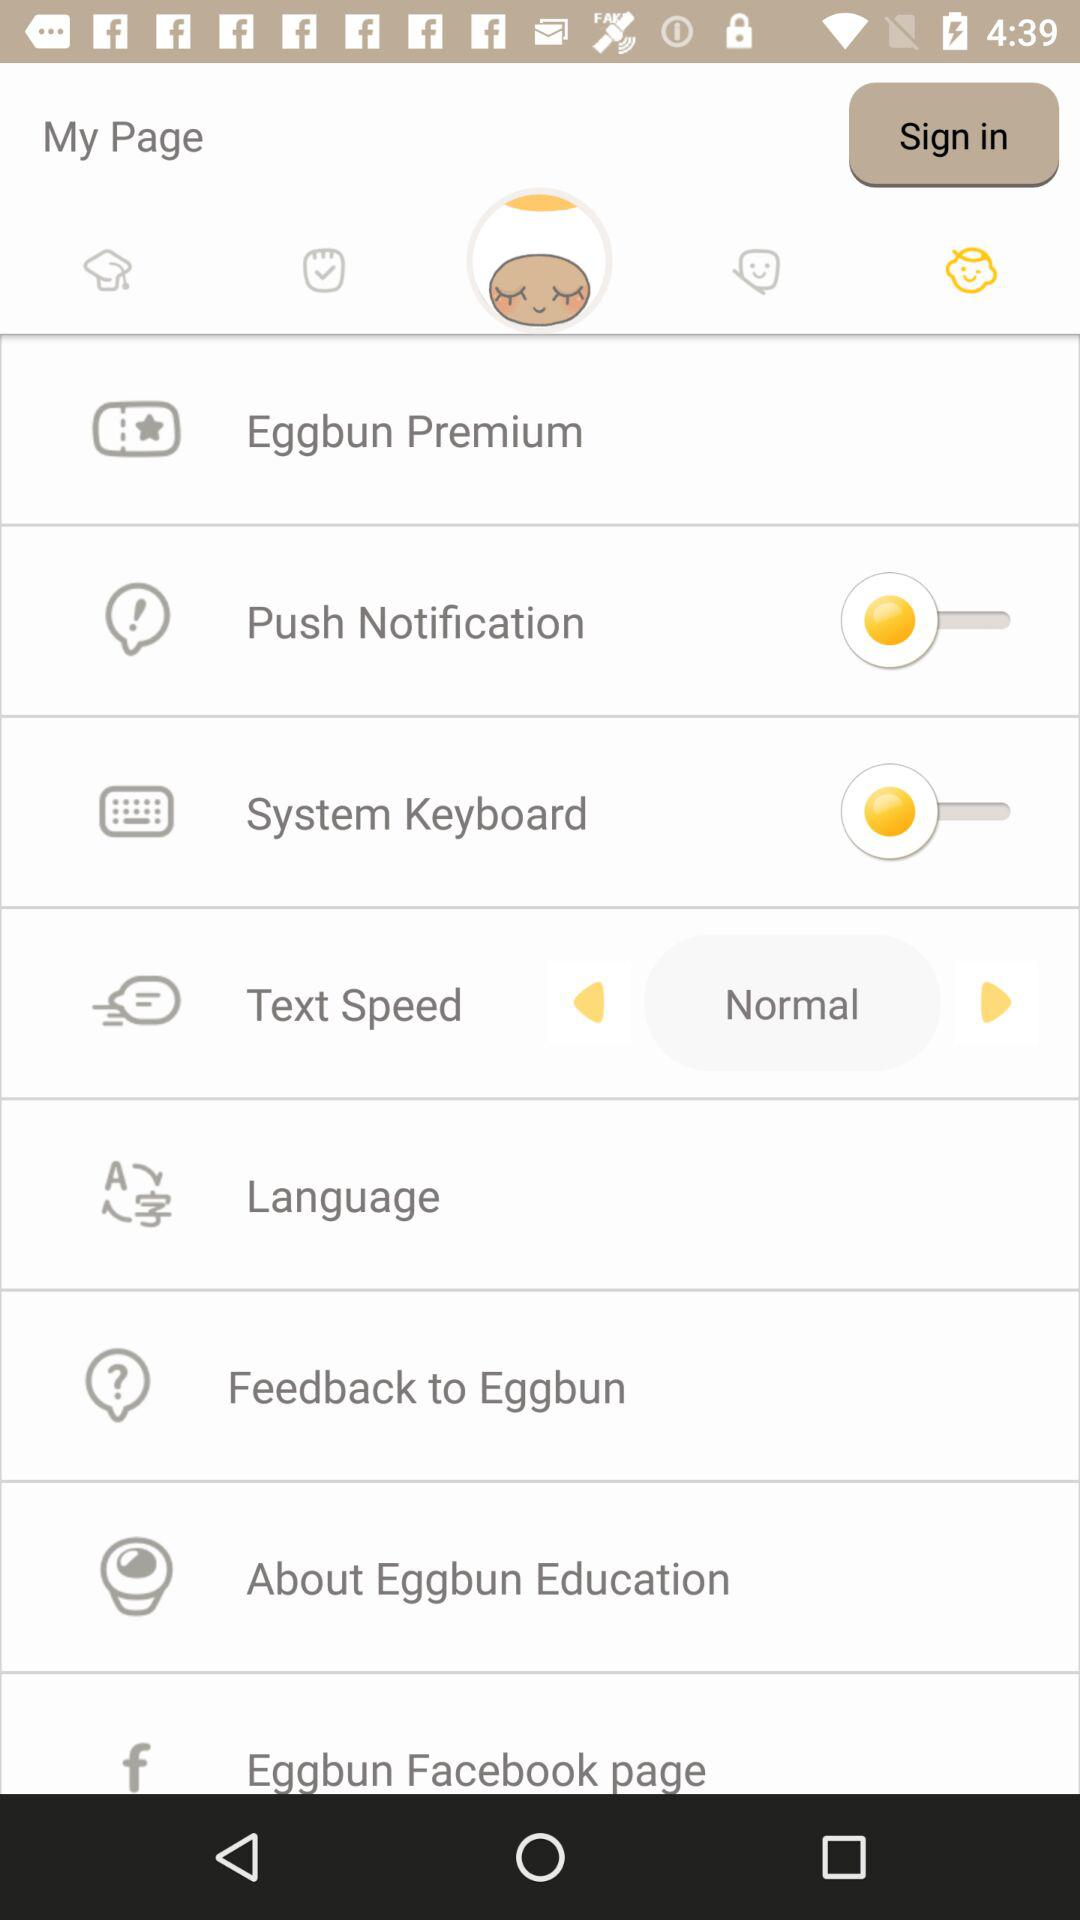Is the "Push Notification" on or off? The "Push Notification" is "off". 